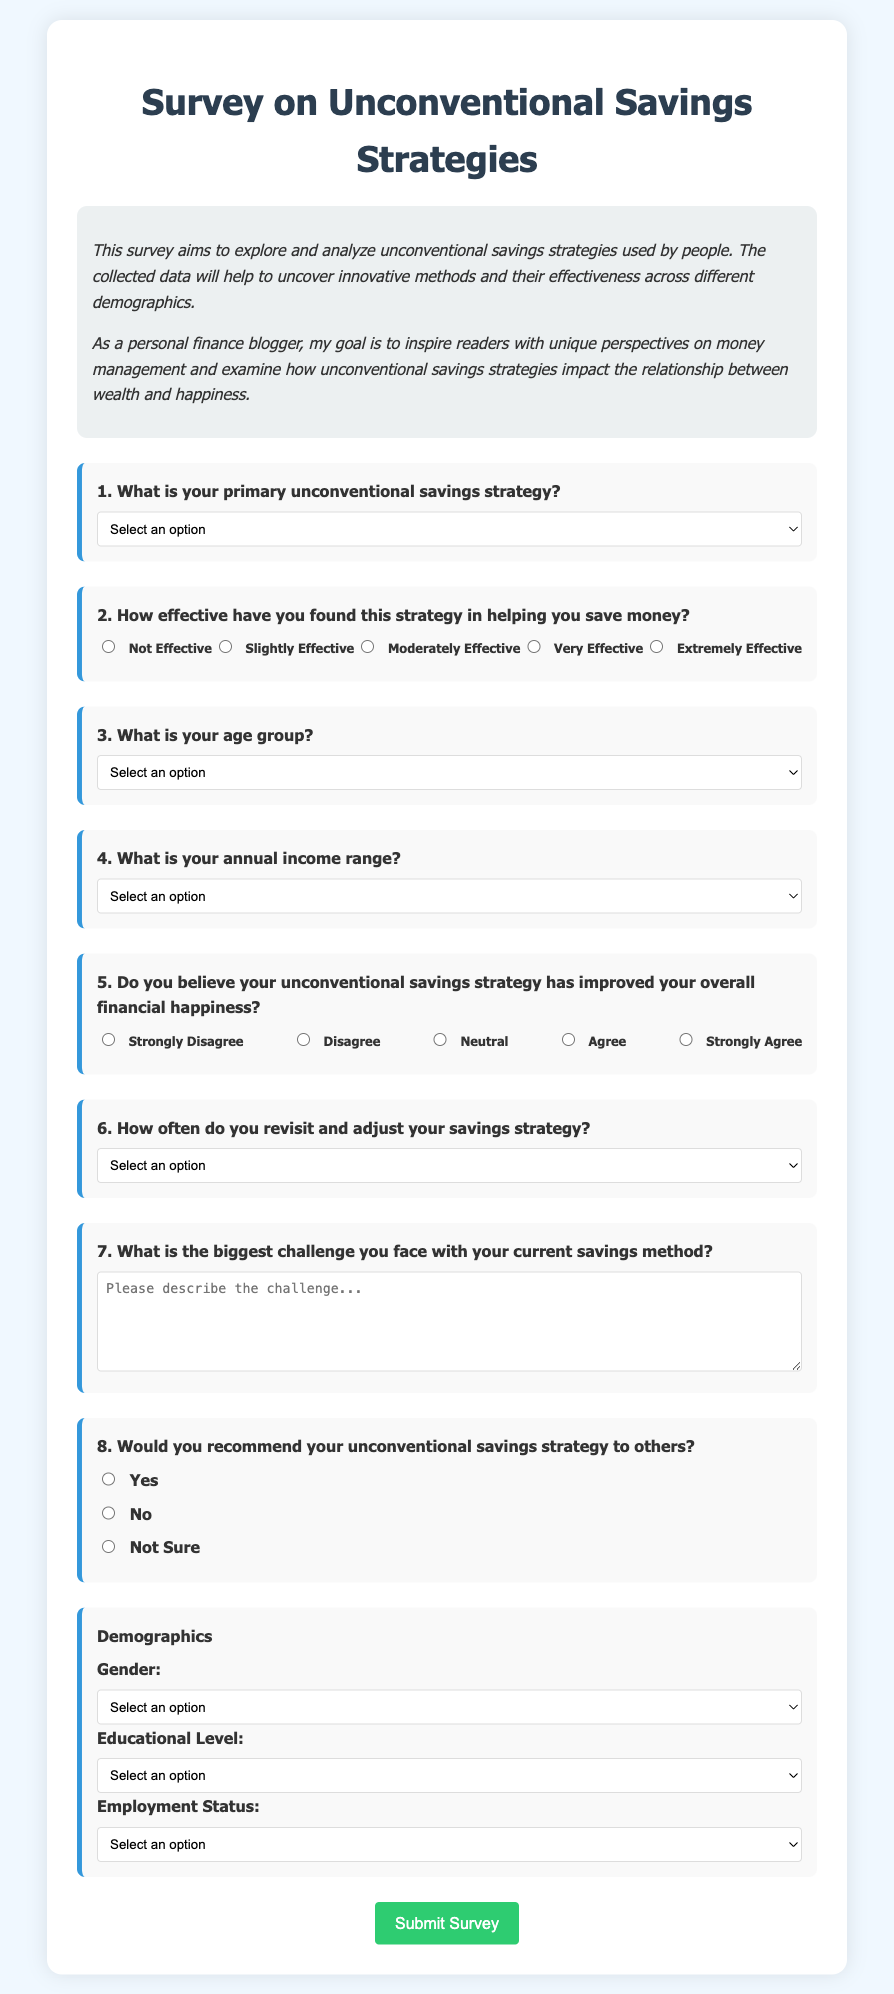What is the primary focus of the survey? The survey aims to explore and analyze unconventional savings strategies used by people.
Answer: Unconventional savings strategies What is the maximum age group option in the survey? The age group options range from 18-24 to 65+, with 65+ being the maximum.
Answer: 65+ How many unconventional savings strategy options are provided in the survey? There are five different unconventional savings strategies listed in the survey.
Answer: Five What is the highest rating for effectiveness in the savings strategy question? The highest rating indicating effectiveness is "Extremely Effective."
Answer: Extremely Effective Which demographic category has multiple options available in the survey? The survey includes comprehensive options for gender, education, and employment status.
Answer: Gender How is the question regarding financial happiness phrased? The question asks whether the respondent believes their unconventional savings strategy has improved their overall financial happiness.
Answer: Improved financial happiness What is the submit button's color in the survey? The visible submit button is styled with a green color for submission.
Answer: Green Which unconventional savings strategy involves using cashback rewards? The option specified for cashback rewards is "Utilizing cashback rewards."
Answer: Utilizing cashback rewards How often do respondents need to address their savings strategy? The options for frequency of revisiting the savings strategy range from weekly to rarely/never.
Answer: Rarely/Never 